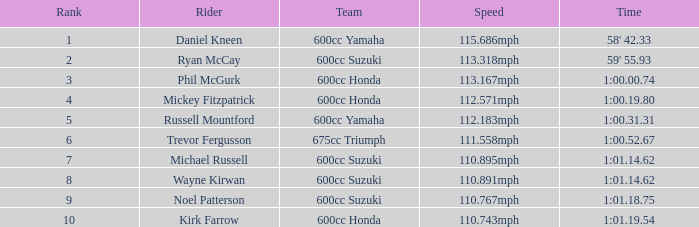At what time is phil mcgurk scheduled as the rider? 1:00.00.74. 